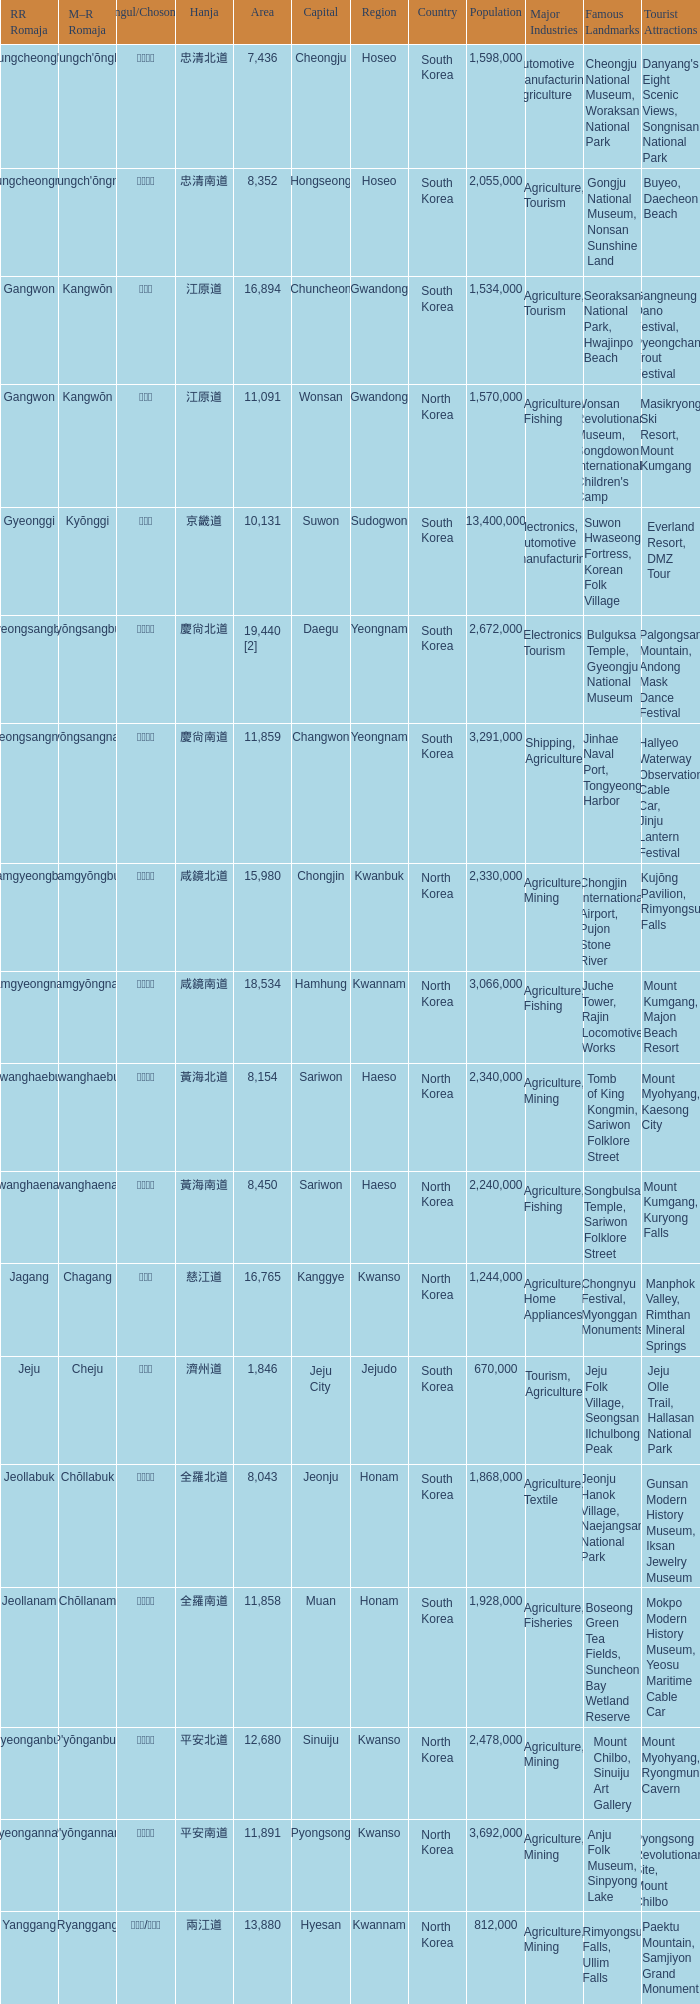What is the RR Romaja for the province that has Hangul of 강원도 and capital of Wonsan? Gangwon. 